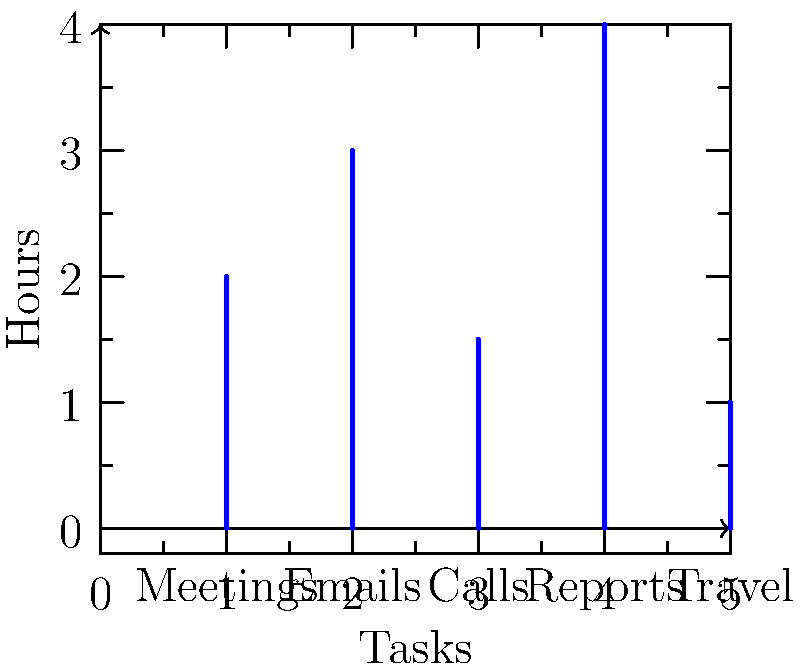Based on the vector representation of Harry Burns' daily schedule, calculate the magnitude of the vector. Each component of the vector represents the time spent (in hours) on different tasks as shown in the bar graph. To calculate the magnitude of the vector representing Harry's daily schedule, we need to follow these steps:

1. Identify the components of the vector:
   $x_1 = 2$ (Meetings)
   $x_2 = 3$ (Emails)
   $x_3 = 1.5$ (Calls)
   $x_4 = 4$ (Reports)
   $x_5 = 1$ (Travel)

2. Use the formula for calculating the magnitude of a vector in 5-dimensional space:
   $\text{Magnitude} = \sqrt{x_1^2 + x_2^2 + x_3^2 + x_4^2 + x_5^2}$

3. Substitute the values:
   $\text{Magnitude} = \sqrt{2^2 + 3^2 + 1.5^2 + 4^2 + 1^2}$

4. Calculate the squares:
   $\text{Magnitude} = \sqrt{4 + 9 + 2.25 + 16 + 1}$

5. Sum the values under the square root:
   $\text{Magnitude} = \sqrt{32.25}$

6. Calculate the square root:
   $\text{Magnitude} \approx 5.68$ hours

The magnitude represents the overall length of the vector, which can be interpreted as a measure of Harry's total daily activity across all tasks.
Answer: $5.68$ hours 